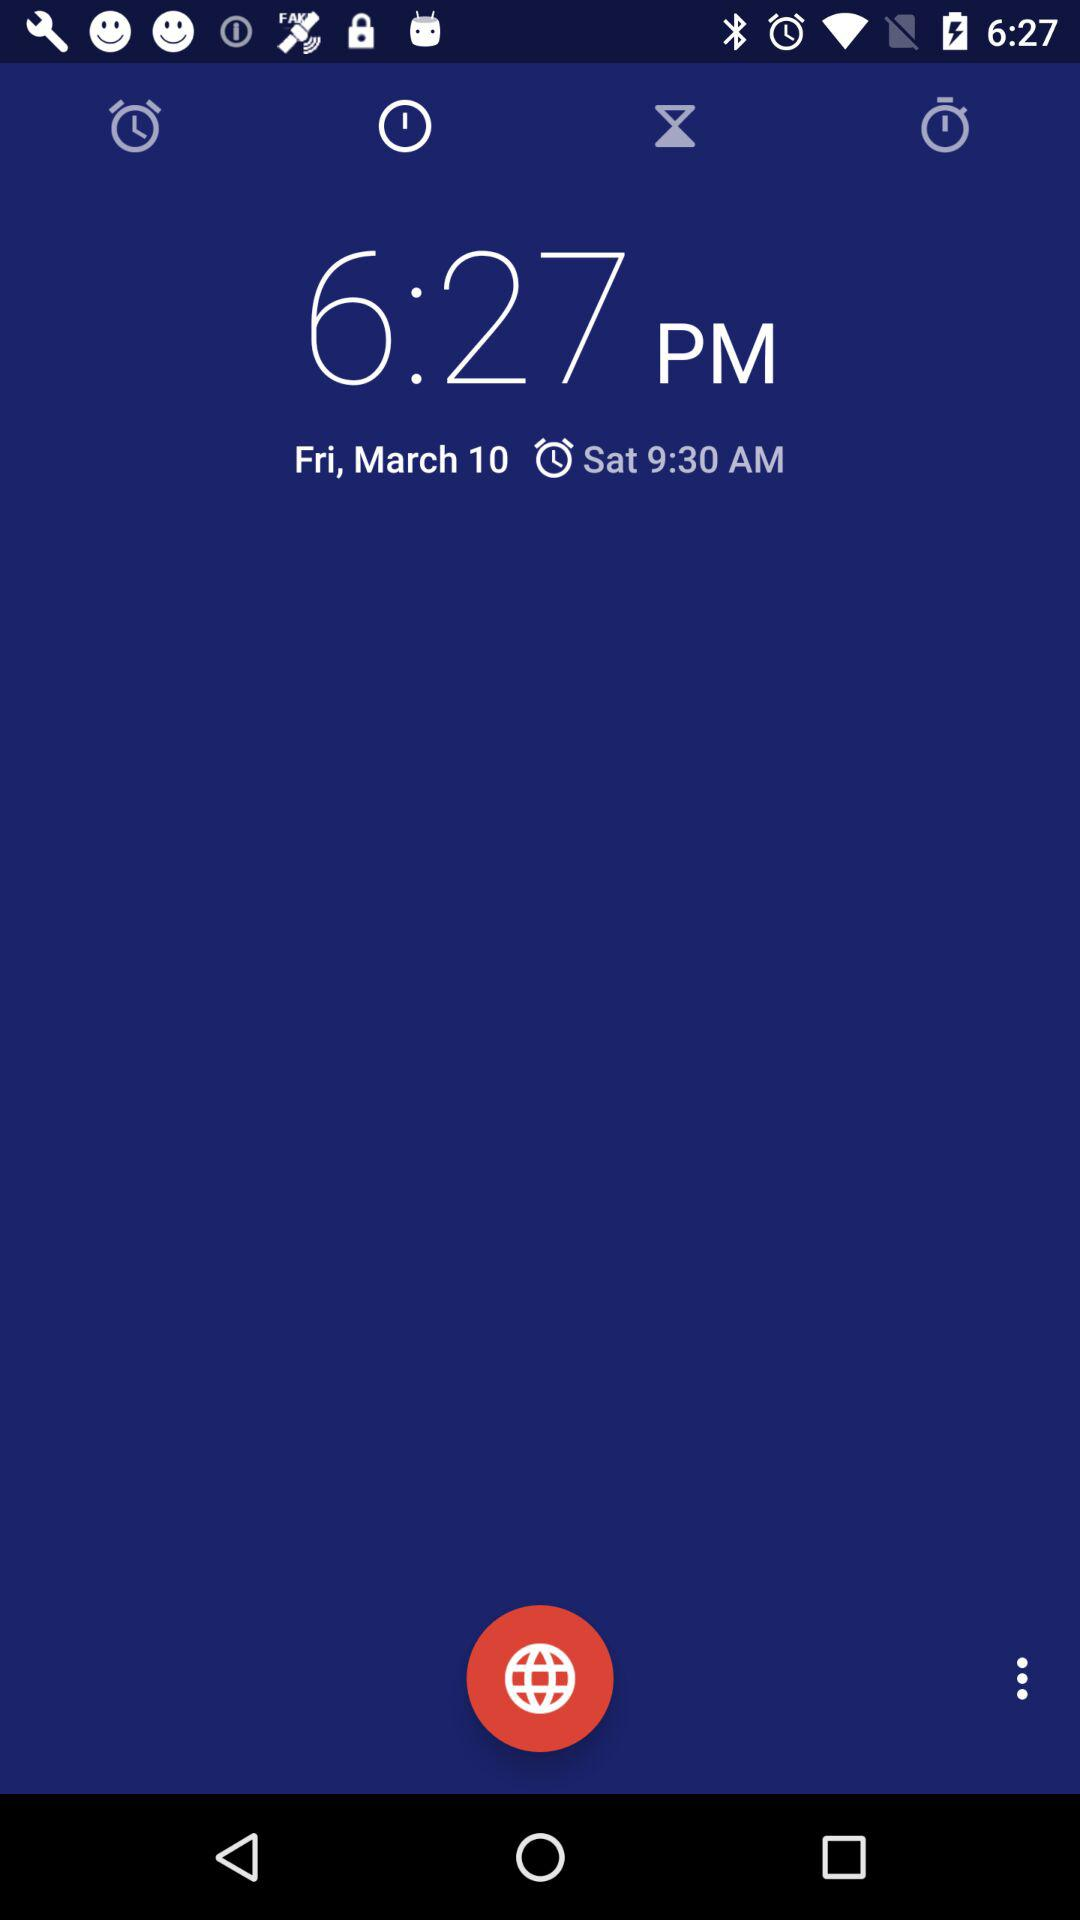What is the alarm time? The alarm time is 9:30 AM. 